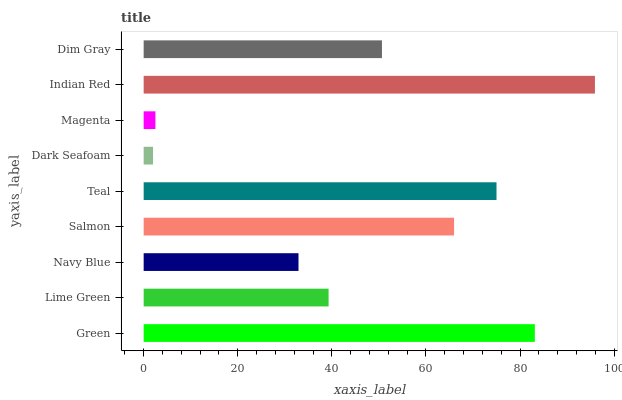Is Dark Seafoam the minimum?
Answer yes or no. Yes. Is Indian Red the maximum?
Answer yes or no. Yes. Is Lime Green the minimum?
Answer yes or no. No. Is Lime Green the maximum?
Answer yes or no. No. Is Green greater than Lime Green?
Answer yes or no. Yes. Is Lime Green less than Green?
Answer yes or no. Yes. Is Lime Green greater than Green?
Answer yes or no. No. Is Green less than Lime Green?
Answer yes or no. No. Is Dim Gray the high median?
Answer yes or no. Yes. Is Dim Gray the low median?
Answer yes or no. Yes. Is Salmon the high median?
Answer yes or no. No. Is Salmon the low median?
Answer yes or no. No. 